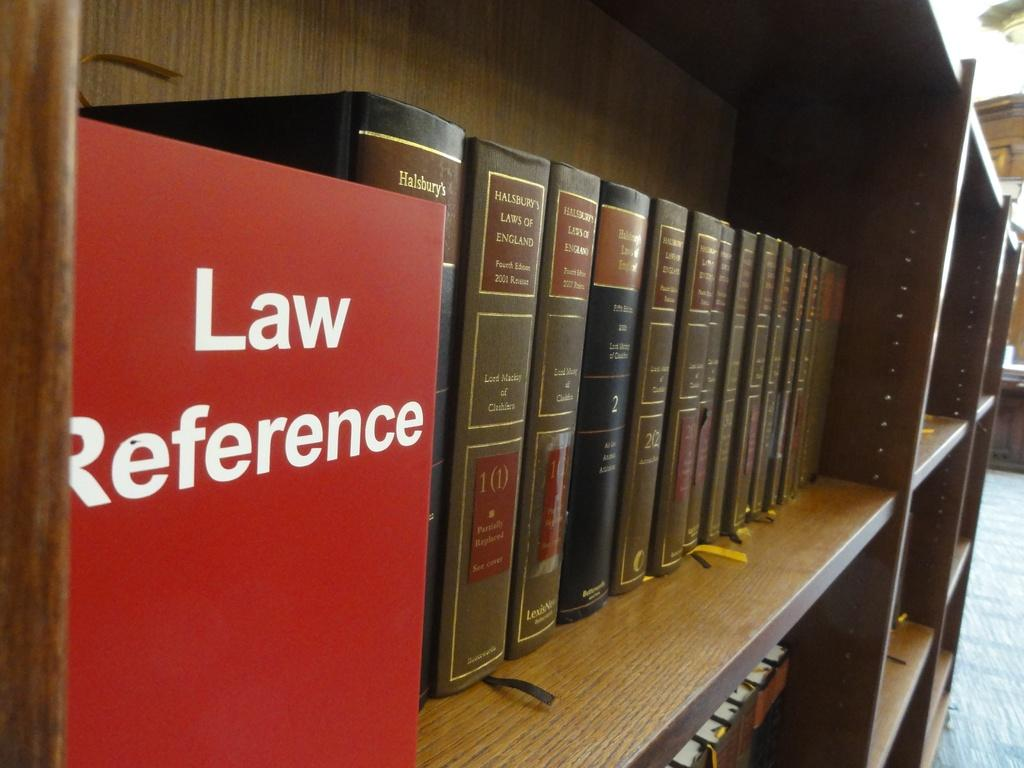<image>
Describe the image concisely. A great many books about Law Reference are lined on shelves in a library. 